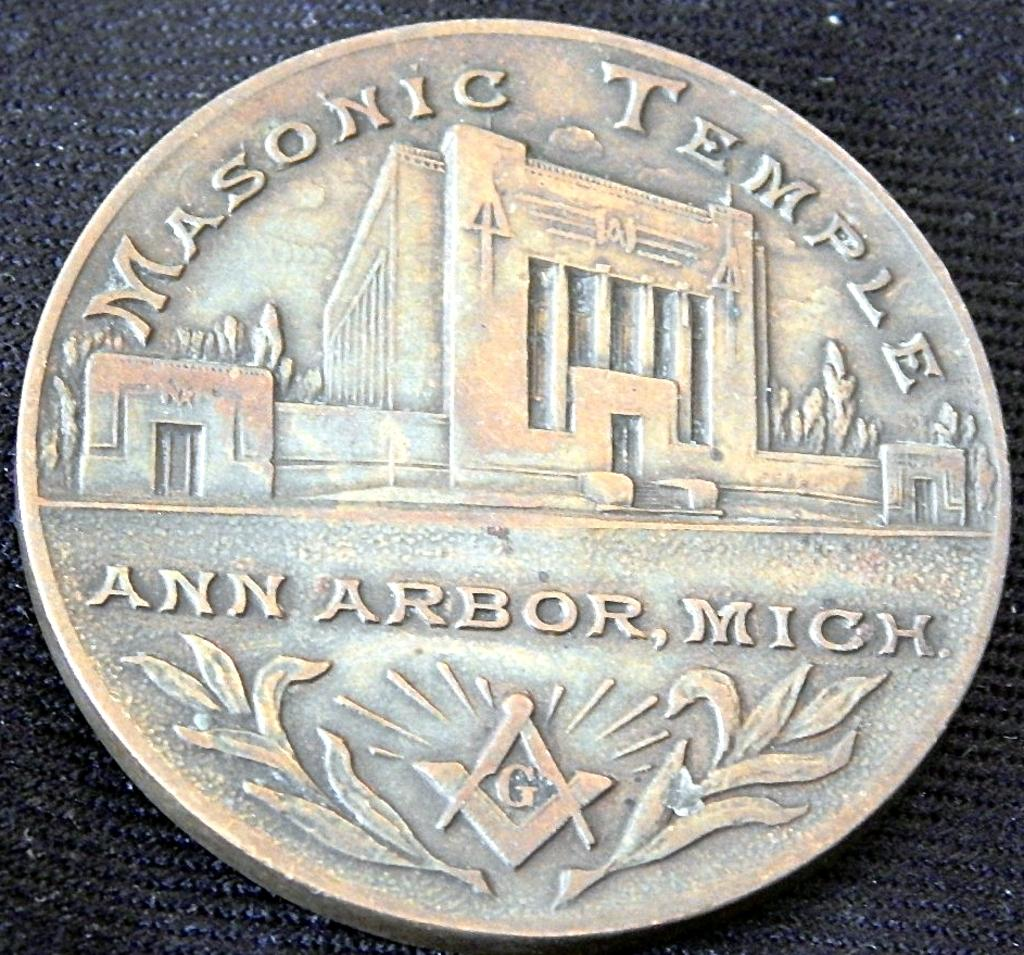Provide a one-sentence caption for the provided image. A coin for the Masonic Temple in Ann Arbor, Mich. shows a building. 